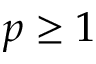<formula> <loc_0><loc_0><loc_500><loc_500>p \geq 1</formula> 